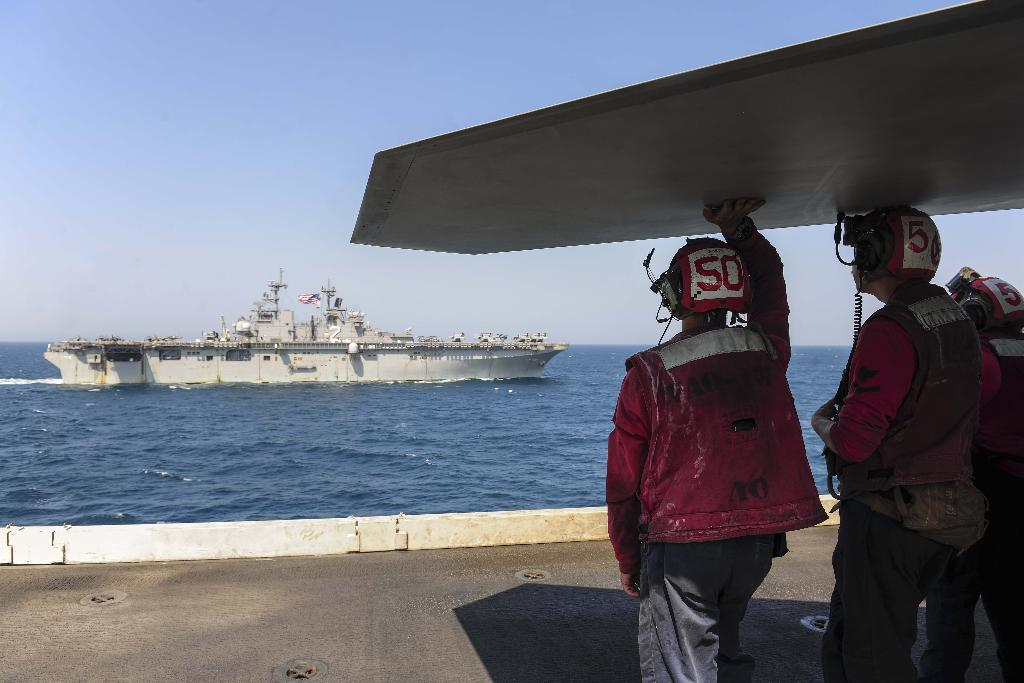<image>
Offer a succinct explanation of the picture presented. Men wearing helmets that say 50 on them are gazing into the water at a ship. 